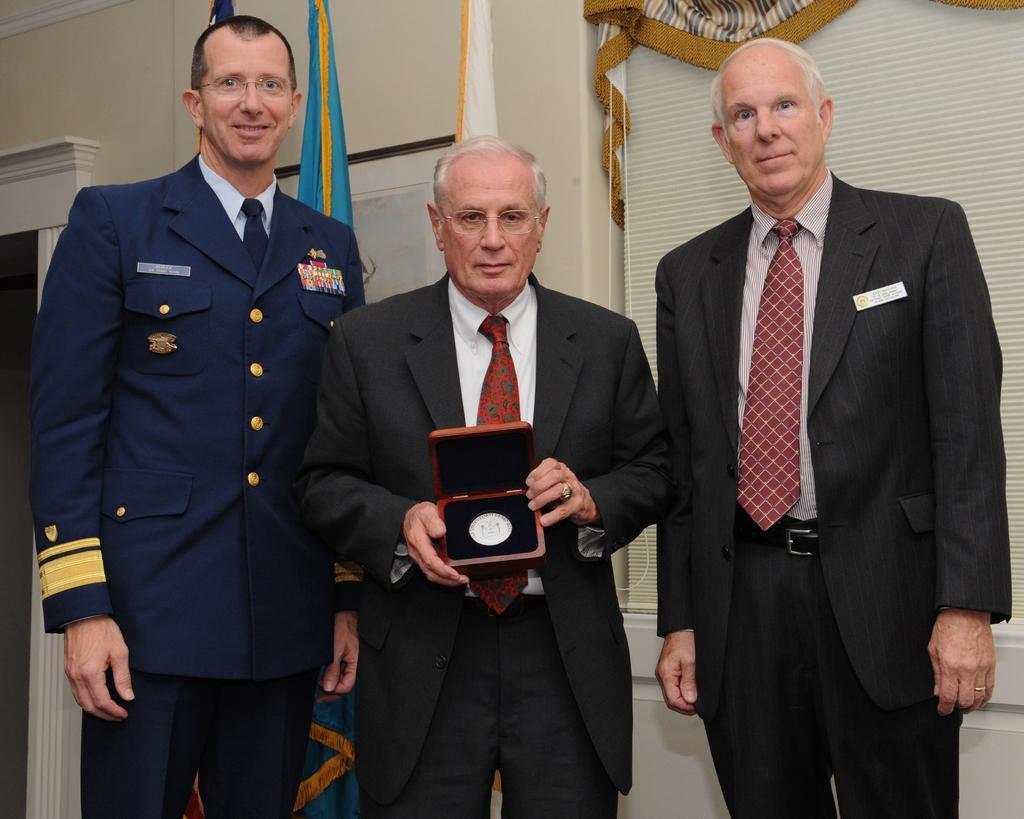Please provide a concise description of this image. This image is taken indoors. In the background there is a wall with a window, a window blind and a curtain and there are two flags. In the middle of the image three men are standing on the floor and a man is holding a box in his hands. 